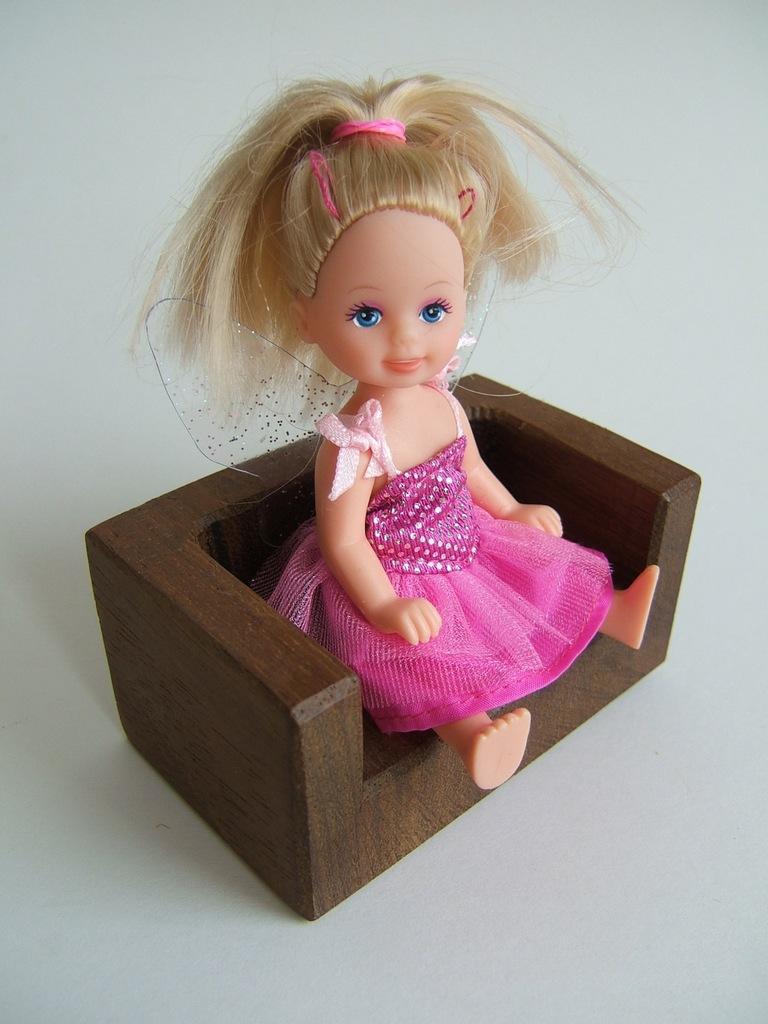Please provide a concise description of this image. In this picture we can see a toy sitting on the chair. 